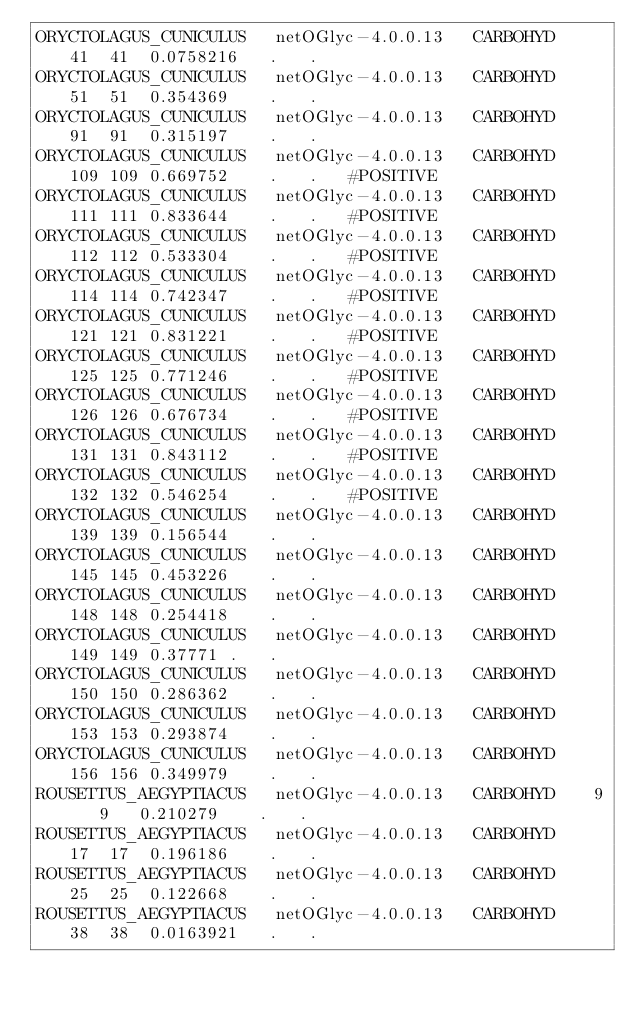<code> <loc_0><loc_0><loc_500><loc_500><_HTML_>ORYCTOLAGUS_CUNICULUS	netOGlyc-4.0.0.13	CARBOHYD	41	41	0.0758216	.	.	
ORYCTOLAGUS_CUNICULUS	netOGlyc-4.0.0.13	CARBOHYD	51	51	0.354369	.	.	
ORYCTOLAGUS_CUNICULUS	netOGlyc-4.0.0.13	CARBOHYD	91	91	0.315197	.	.	
ORYCTOLAGUS_CUNICULUS	netOGlyc-4.0.0.13	CARBOHYD	109	109	0.669752	.	.	#POSITIVE
ORYCTOLAGUS_CUNICULUS	netOGlyc-4.0.0.13	CARBOHYD	111	111	0.833644	.	.	#POSITIVE
ORYCTOLAGUS_CUNICULUS	netOGlyc-4.0.0.13	CARBOHYD	112	112	0.533304	.	.	#POSITIVE
ORYCTOLAGUS_CUNICULUS	netOGlyc-4.0.0.13	CARBOHYD	114	114	0.742347	.	.	#POSITIVE
ORYCTOLAGUS_CUNICULUS	netOGlyc-4.0.0.13	CARBOHYD	121	121	0.831221	.	.	#POSITIVE
ORYCTOLAGUS_CUNICULUS	netOGlyc-4.0.0.13	CARBOHYD	125	125	0.771246	.	.	#POSITIVE
ORYCTOLAGUS_CUNICULUS	netOGlyc-4.0.0.13	CARBOHYD	126	126	0.676734	.	.	#POSITIVE
ORYCTOLAGUS_CUNICULUS	netOGlyc-4.0.0.13	CARBOHYD	131	131	0.843112	.	.	#POSITIVE
ORYCTOLAGUS_CUNICULUS	netOGlyc-4.0.0.13	CARBOHYD	132	132	0.546254	.	.	#POSITIVE
ORYCTOLAGUS_CUNICULUS	netOGlyc-4.0.0.13	CARBOHYD	139	139	0.156544	.	.	
ORYCTOLAGUS_CUNICULUS	netOGlyc-4.0.0.13	CARBOHYD	145	145	0.453226	.	.	
ORYCTOLAGUS_CUNICULUS	netOGlyc-4.0.0.13	CARBOHYD	148	148	0.254418	.	.	
ORYCTOLAGUS_CUNICULUS	netOGlyc-4.0.0.13	CARBOHYD	149	149	0.37771	.	.	
ORYCTOLAGUS_CUNICULUS	netOGlyc-4.0.0.13	CARBOHYD	150	150	0.286362	.	.	
ORYCTOLAGUS_CUNICULUS	netOGlyc-4.0.0.13	CARBOHYD	153	153	0.293874	.	.	
ORYCTOLAGUS_CUNICULUS	netOGlyc-4.0.0.13	CARBOHYD	156	156	0.349979	.	.	
ROUSETTUS_AEGYPTIACUS	netOGlyc-4.0.0.13	CARBOHYD	9	9	0.210279	.	.	
ROUSETTUS_AEGYPTIACUS	netOGlyc-4.0.0.13	CARBOHYD	17	17	0.196186	.	.	
ROUSETTUS_AEGYPTIACUS	netOGlyc-4.0.0.13	CARBOHYD	25	25	0.122668	.	.	
ROUSETTUS_AEGYPTIACUS	netOGlyc-4.0.0.13	CARBOHYD	38	38	0.0163921	.	.	</code> 